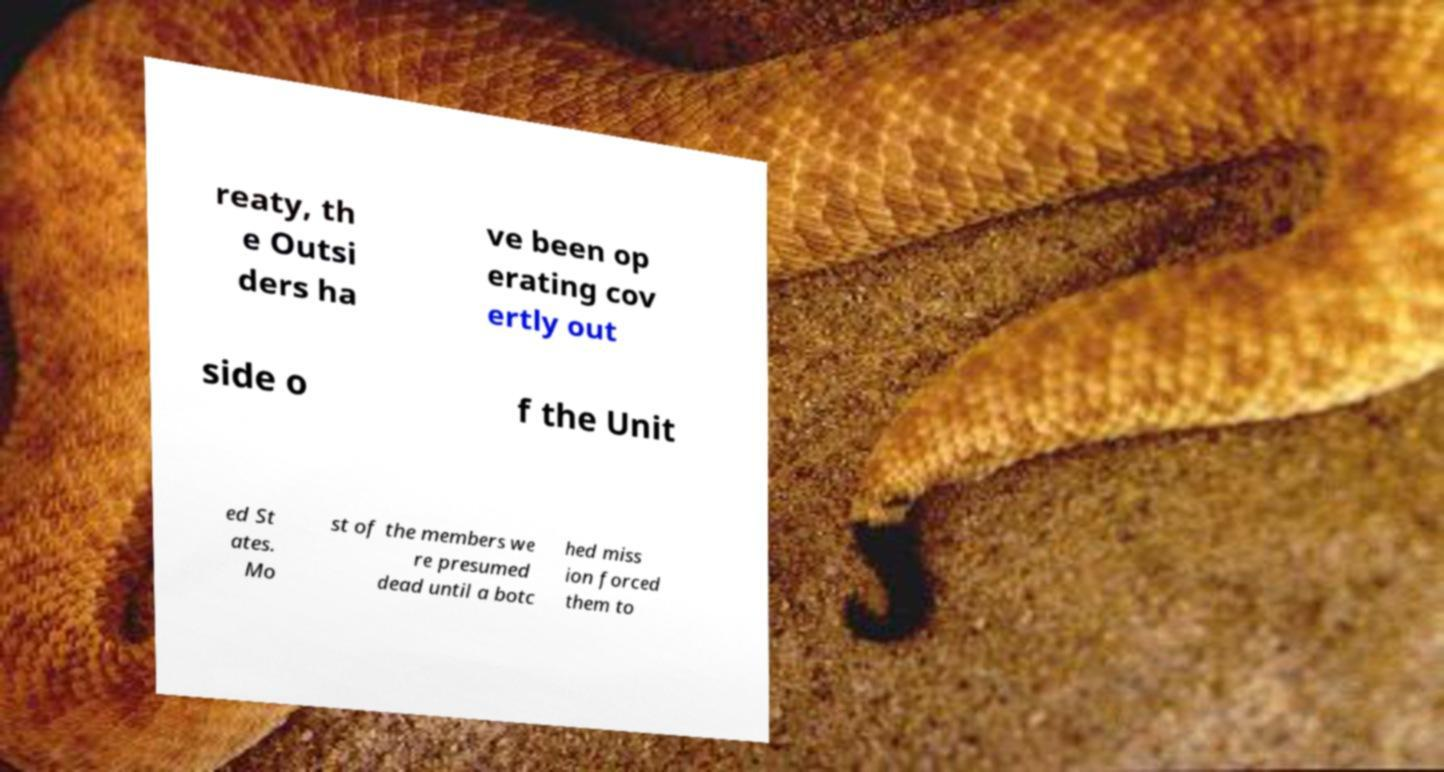I need the written content from this picture converted into text. Can you do that? reaty, th e Outsi ders ha ve been op erating cov ertly out side o f the Unit ed St ates. Mo st of the members we re presumed dead until a botc hed miss ion forced them to 